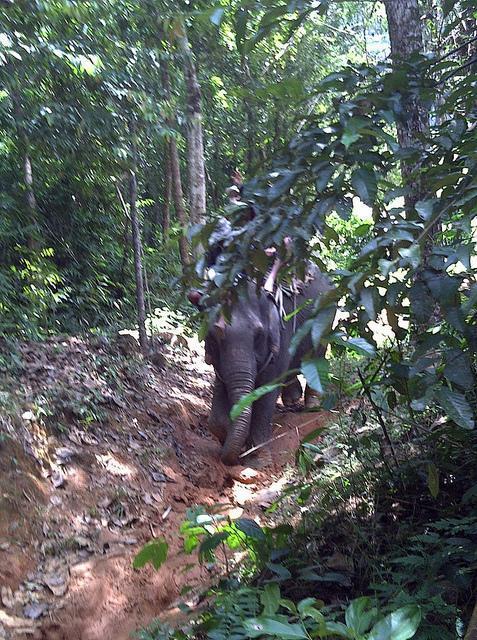How many round donuts have nuts on them in the image?
Give a very brief answer. 0. 